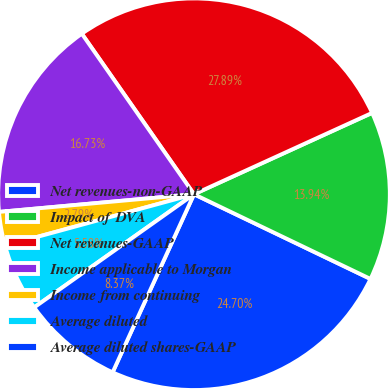<chart> <loc_0><loc_0><loc_500><loc_500><pie_chart><fcel>Net revenues-non-GAAP<fcel>Impact of DVA<fcel>Net revenues-GAAP<fcel>Income applicable to Morgan<fcel>Income from continuing<fcel>Average diluted<fcel>Average diluted shares-GAAP<nl><fcel>24.7%<fcel>13.94%<fcel>27.89%<fcel>16.73%<fcel>2.79%<fcel>5.58%<fcel>8.37%<nl></chart> 